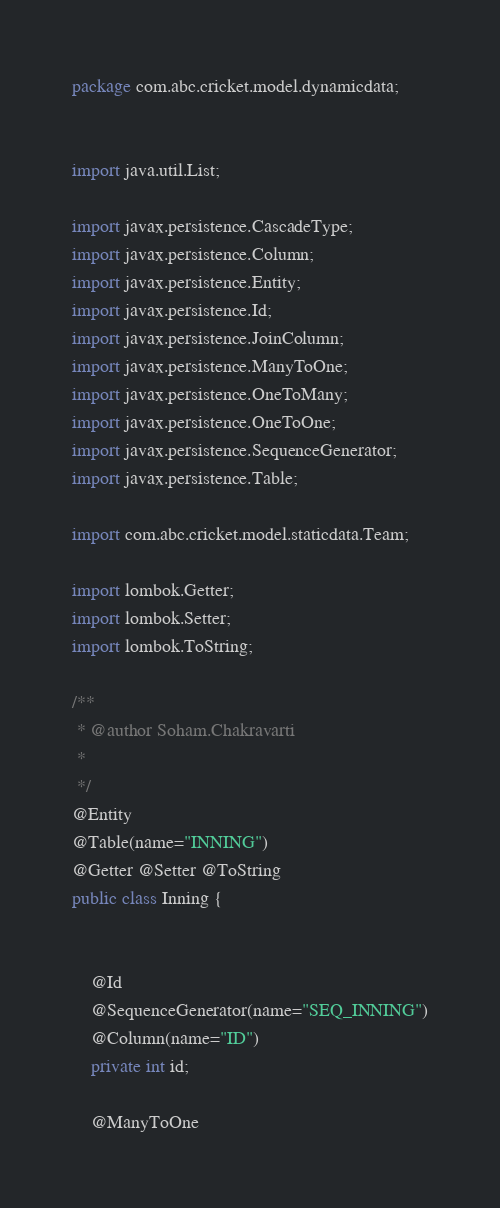<code> <loc_0><loc_0><loc_500><loc_500><_Java_>package com.abc.cricket.model.dynamicdata;


import java.util.List;

import javax.persistence.CascadeType;
import javax.persistence.Column;
import javax.persistence.Entity;
import javax.persistence.Id;
import javax.persistence.JoinColumn;
import javax.persistence.ManyToOne;
import javax.persistence.OneToMany;
import javax.persistence.OneToOne;
import javax.persistence.SequenceGenerator;
import javax.persistence.Table;

import com.abc.cricket.model.staticdata.Team;

import lombok.Getter;
import lombok.Setter;
import lombok.ToString;

/**
 * @author Soham.Chakravarti
 *
 */
@Entity
@Table(name="INNING")
@Getter @Setter @ToString
public class Inning {

	
	@Id
	@SequenceGenerator(name="SEQ_INNING")
	@Column(name="ID")
	private int id;
	
	@ManyToOne</code> 